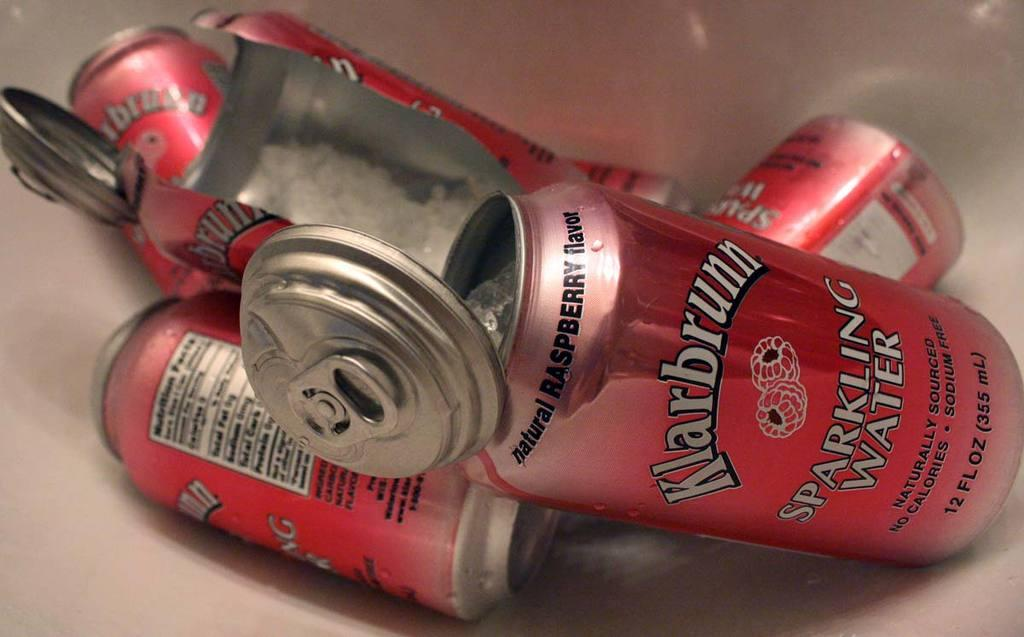<image>
Offer a succinct explanation of the picture presented. a red can that says sparkling water is being used to hide things 